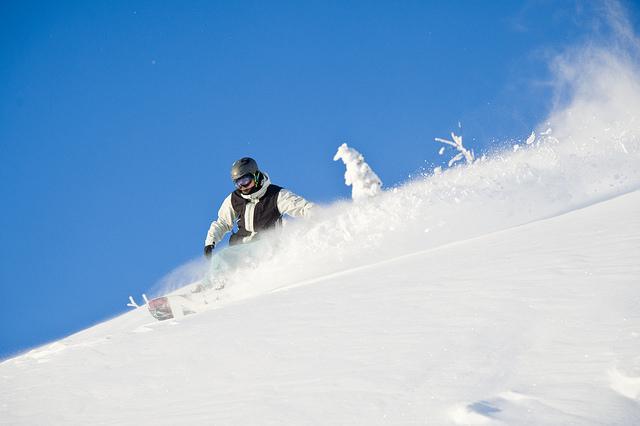Is the snowboarder going fast?
Give a very brief answer. Yes. Is this person flying?
Keep it brief. No. What is the person wearing on their head?
Concise answer only. Helmet. What color is the sky?
Quick response, please. Blue. What's in the snow?
Be succinct. Snowboarder. Has it just snowed?
Answer briefly. Yes. 